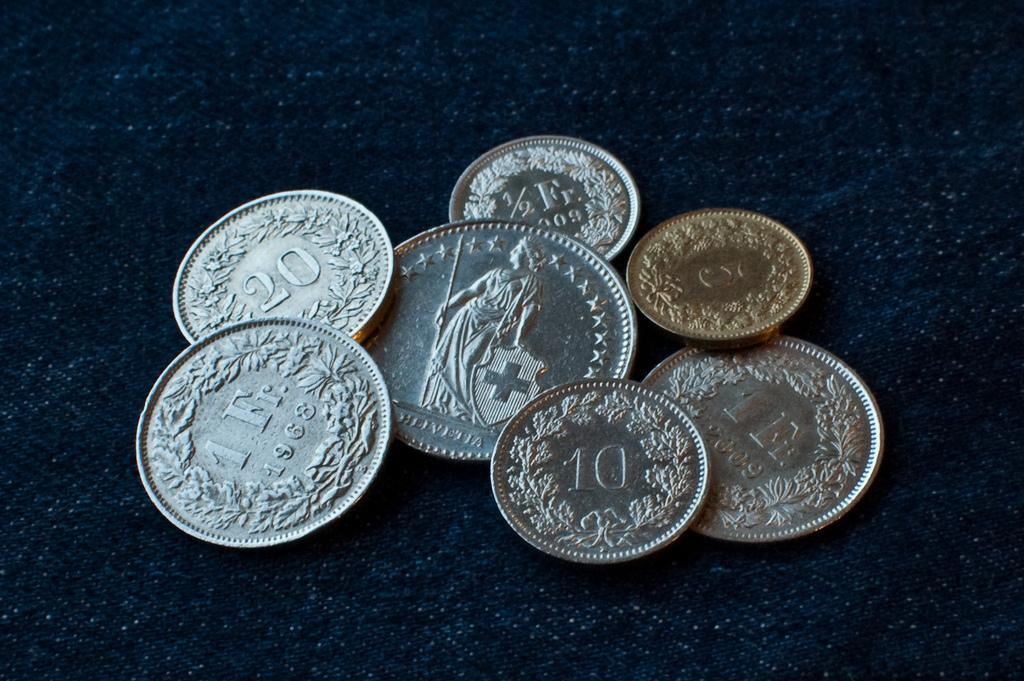Provide a one-sentence caption for the provided image. Seven metallic coins next to each other including one from 1968. 